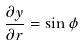<formula> <loc_0><loc_0><loc_500><loc_500>\frac { \partial y } { \partial r } = \sin \phi</formula> 